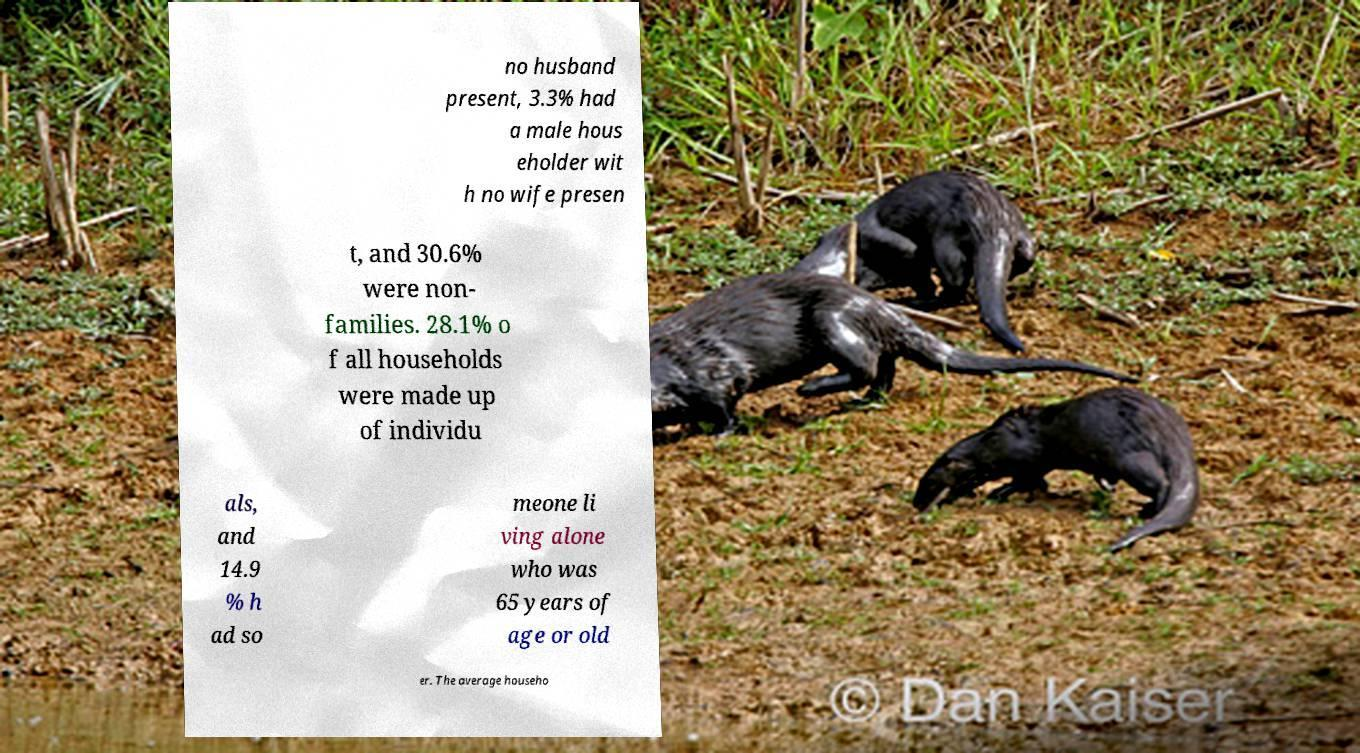What messages or text are displayed in this image? I need them in a readable, typed format. no husband present, 3.3% had a male hous eholder wit h no wife presen t, and 30.6% were non- families. 28.1% o f all households were made up of individu als, and 14.9 % h ad so meone li ving alone who was 65 years of age or old er. The average househo 